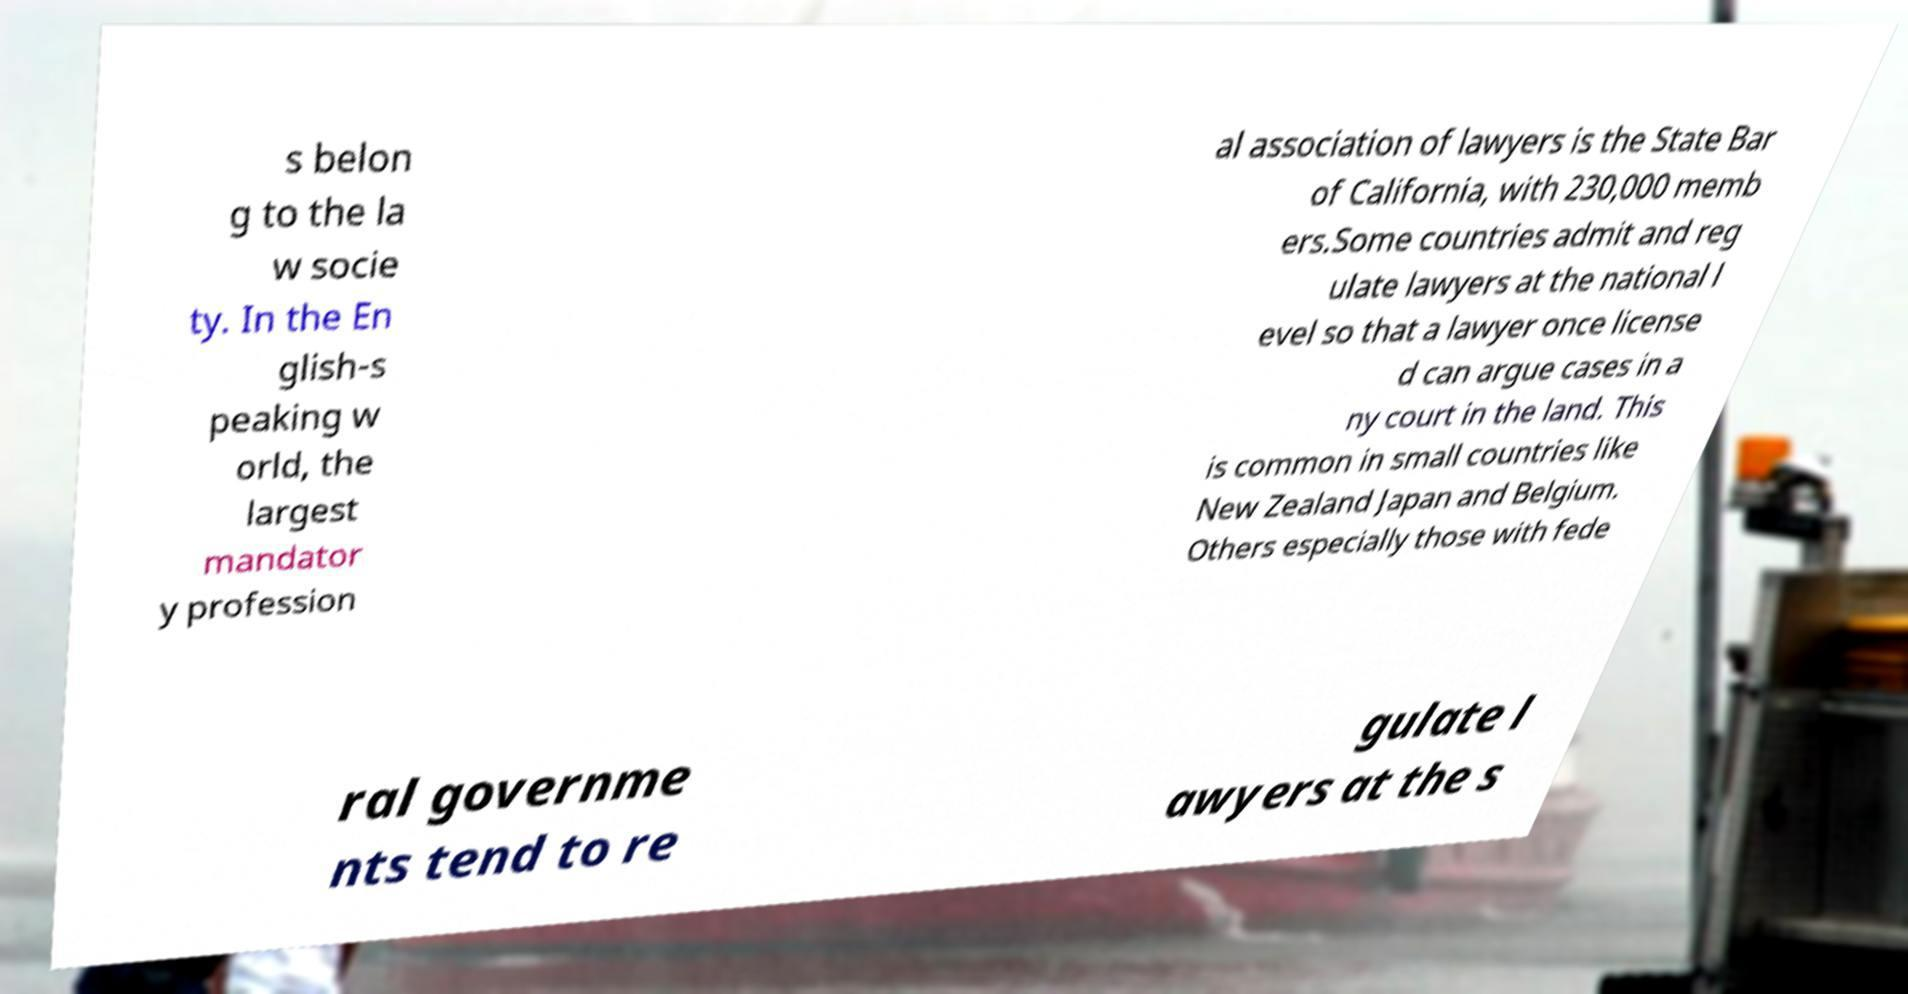Could you extract and type out the text from this image? s belon g to the la w socie ty. In the En glish-s peaking w orld, the largest mandator y profession al association of lawyers is the State Bar of California, with 230,000 memb ers.Some countries admit and reg ulate lawyers at the national l evel so that a lawyer once license d can argue cases in a ny court in the land. This is common in small countries like New Zealand Japan and Belgium. Others especially those with fede ral governme nts tend to re gulate l awyers at the s 